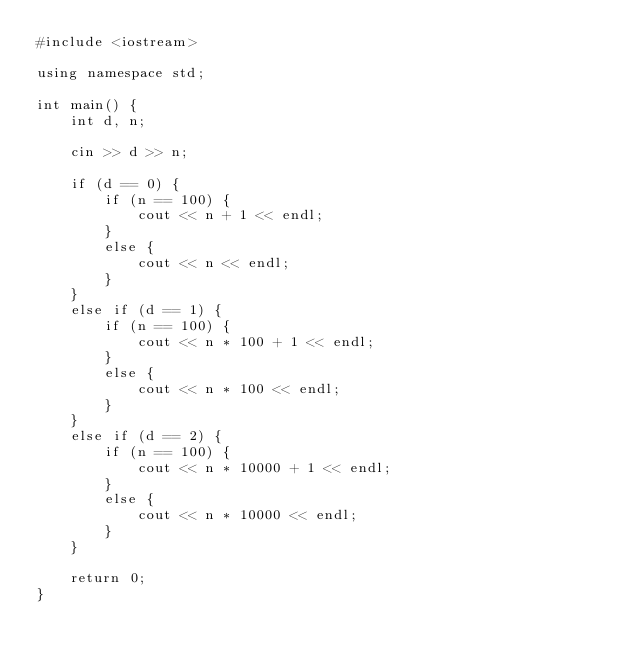Convert code to text. <code><loc_0><loc_0><loc_500><loc_500><_C++_>#include <iostream>

using namespace std;

int main() {
	int d, n;

	cin >> d >> n;

	if (d == 0) {
		if (n == 100) {
			cout << n + 1 << endl;
		}
		else {
			cout << n << endl;
		}
	}
	else if (d == 1) {
		if (n == 100) {
			cout << n * 100 + 1 << endl;
		}
		else {
			cout << n * 100 << endl;
		}
	}
	else if (d == 2) {
		if (n == 100) {
			cout << n * 10000 + 1 << endl;
		}
		else {
			cout << n * 10000 << endl;
		}
	}

	return 0;
}
</code> 